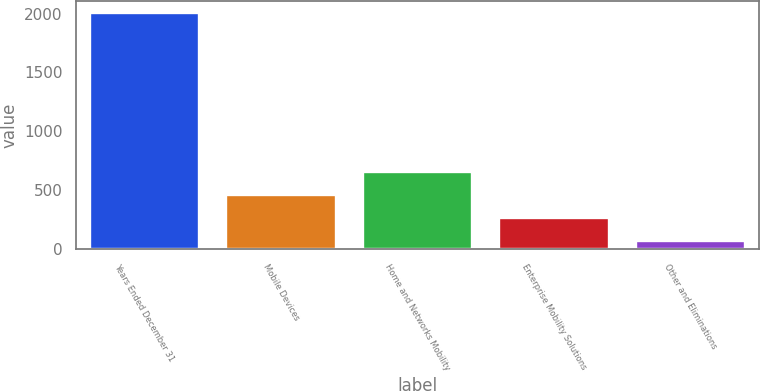<chart> <loc_0><loc_0><loc_500><loc_500><bar_chart><fcel>Years Ended December 31<fcel>Mobile Devices<fcel>Home and Networks Mobility<fcel>Enterprise Mobility Solutions<fcel>Other and Eliminations<nl><fcel>2005<fcel>455.4<fcel>649.1<fcel>261.7<fcel>68<nl></chart> 